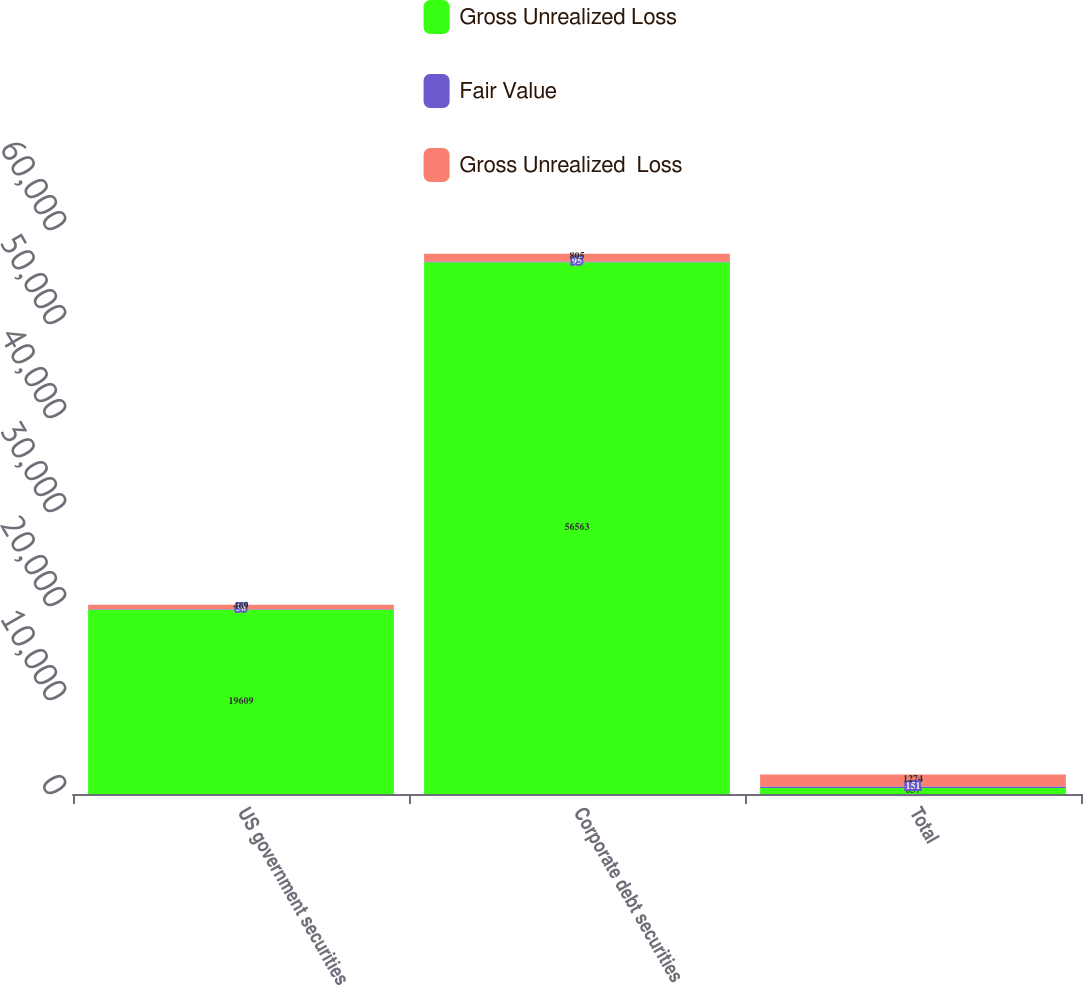<chart> <loc_0><loc_0><loc_500><loc_500><stacked_bar_chart><ecel><fcel>US government securities<fcel>Corporate debt securities<fcel>Total<nl><fcel>Gross Unrealized Loss<fcel>19609<fcel>56563<fcel>637<nl><fcel>Fair Value<fcel>56<fcel>95<fcel>151<nl><fcel>Gross Unrealized  Loss<fcel>469<fcel>805<fcel>1274<nl></chart> 